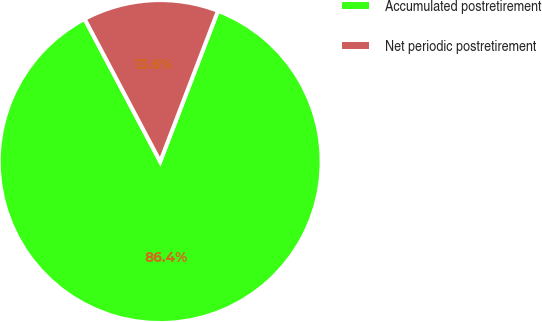Convert chart to OTSL. <chart><loc_0><loc_0><loc_500><loc_500><pie_chart><fcel>Accumulated postretirement<fcel>Net periodic postretirement<nl><fcel>86.42%<fcel>13.58%<nl></chart> 